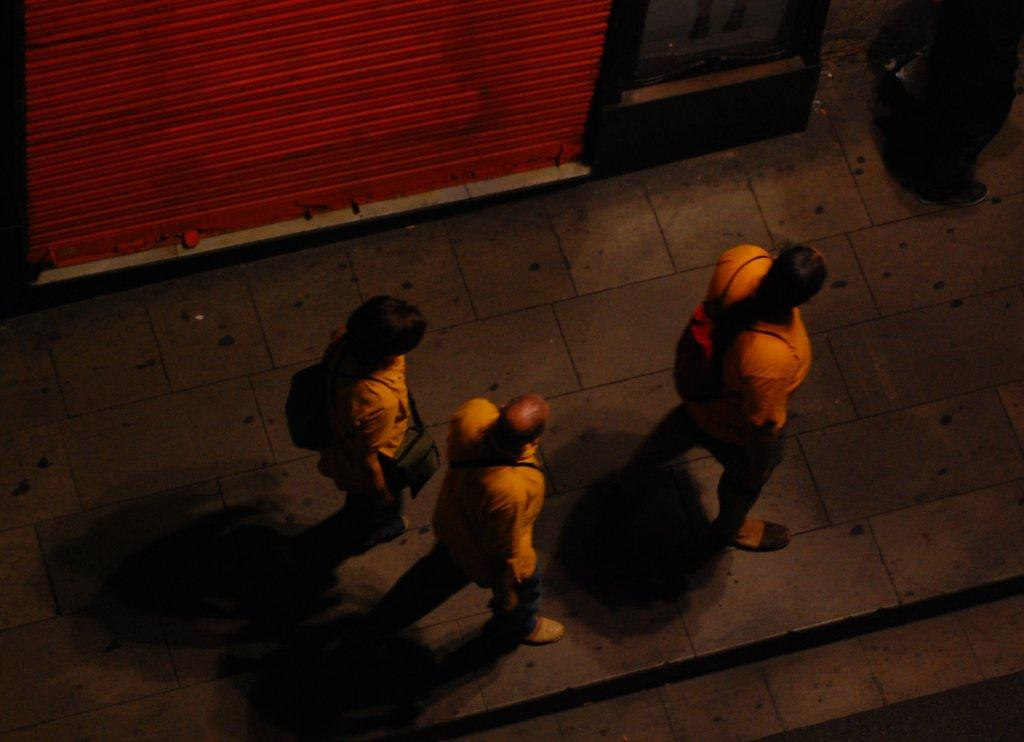What are the people in the image doing? The people in the image are walking on the ground. What can be seen in the background of the image? There is a shutter visible in the background of the image, along with some objects. What type of music is being played by the laborer in the image? There is no laborer or music present in the image; it only shows people walking on the ground and a shutter in the background. 